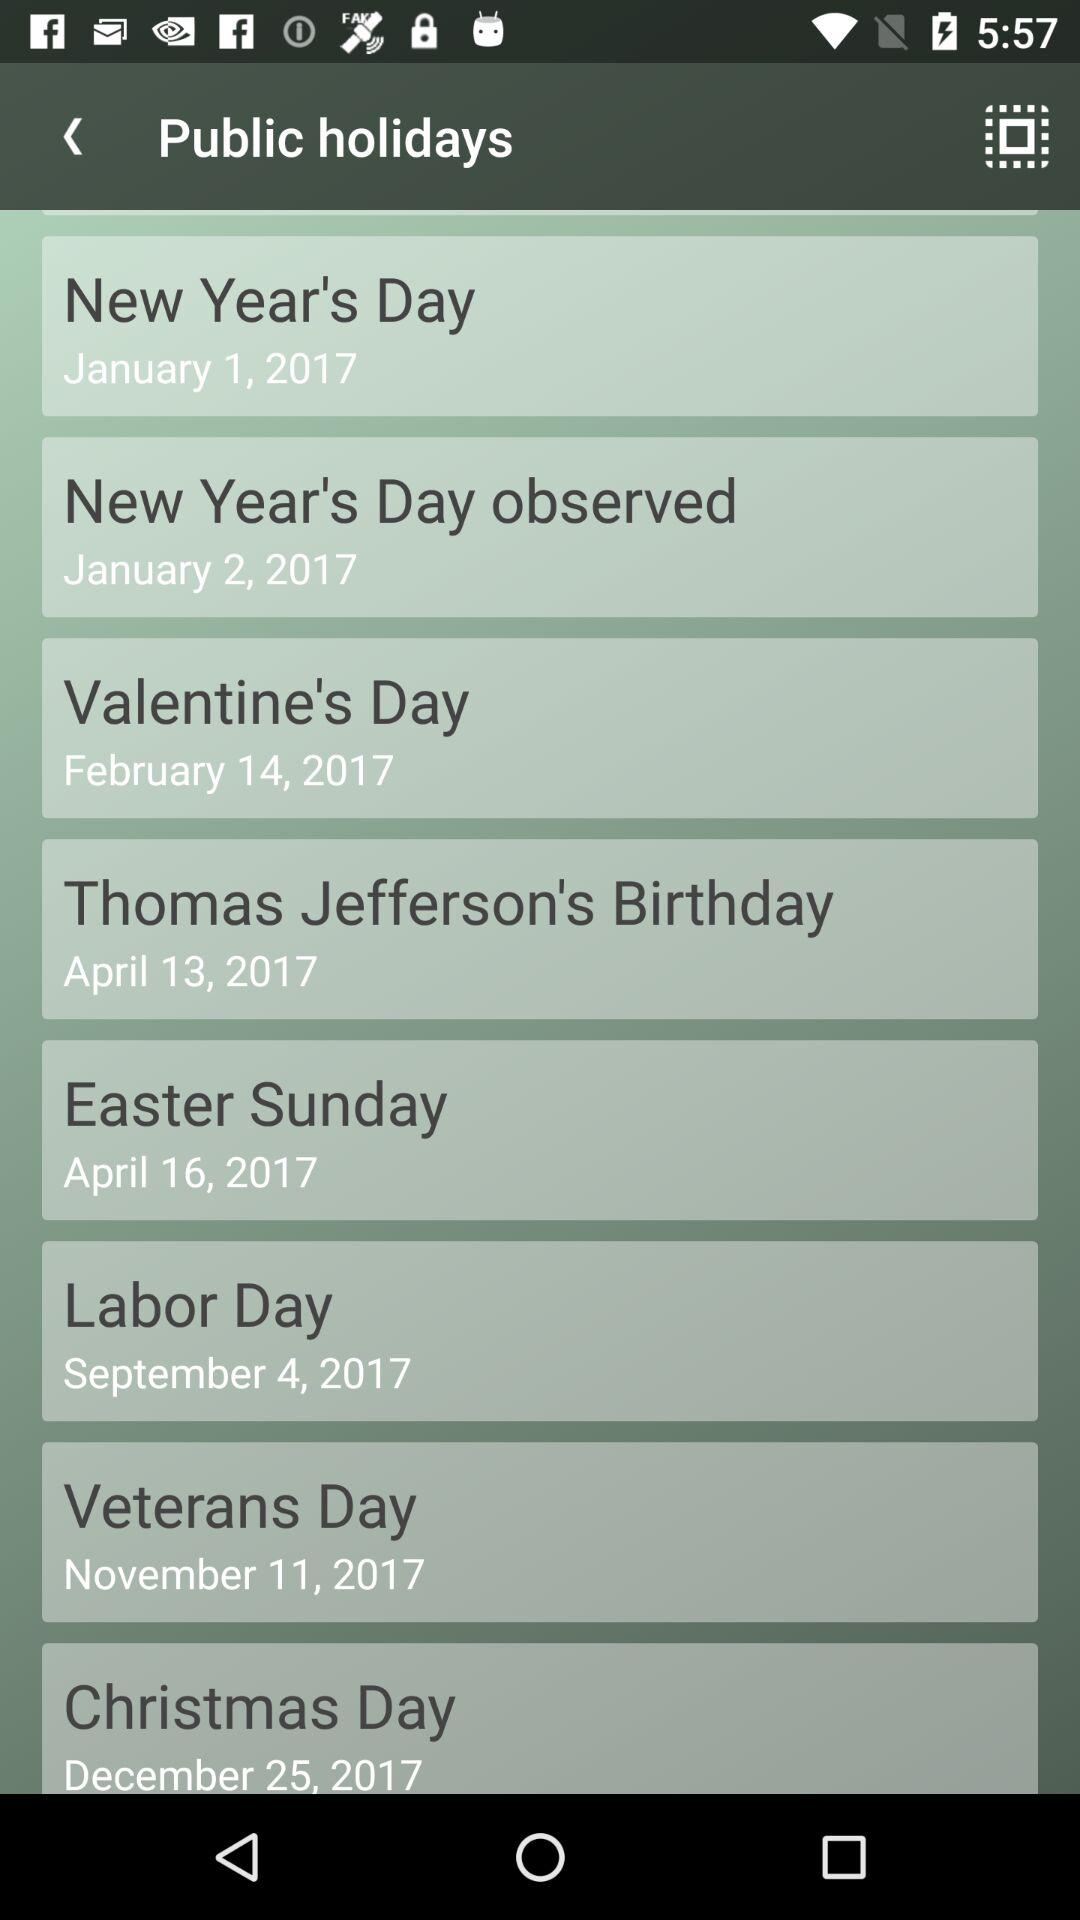When does Christmas Day come? Christmas Day comes on December 25, 2017. 